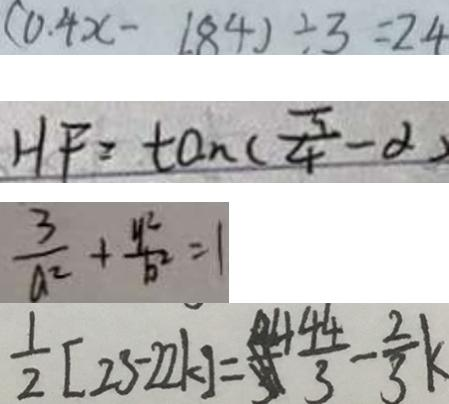Convert formula to latex. <formula><loc_0><loc_0><loc_500><loc_500>( 0 . 4 x - 1 . 8 4 ) \div 3 = 2 . 4 
 H F = \tan ( \frac { \pi } { 4 } - \alpha ) 
 \frac { 3 } { a ^ { 2 } } + \frac { y ^ { 2 } } { b ^ { 2 } } = 1 
 \frac { 1 } { 2 } [ 2 3 - 2 2 k ] = \frac { 4 4 } { 3 } - \frac { 2 } { 3 } k</formula> 